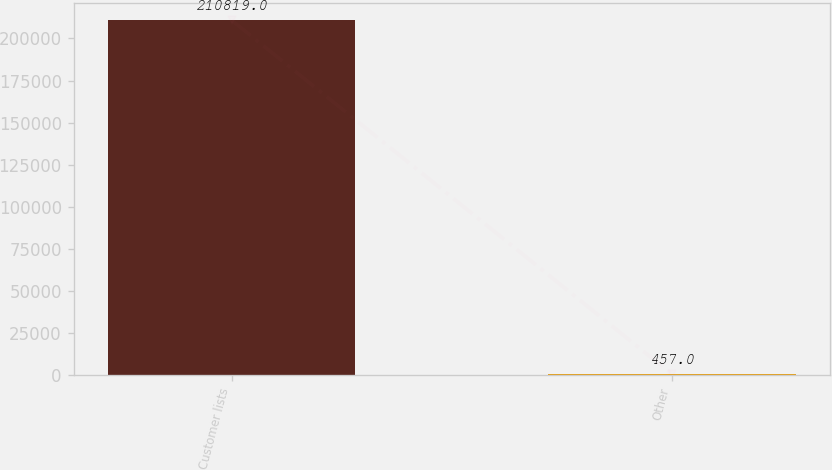Convert chart. <chart><loc_0><loc_0><loc_500><loc_500><bar_chart><fcel>Customer lists<fcel>Other<nl><fcel>210819<fcel>457<nl></chart> 